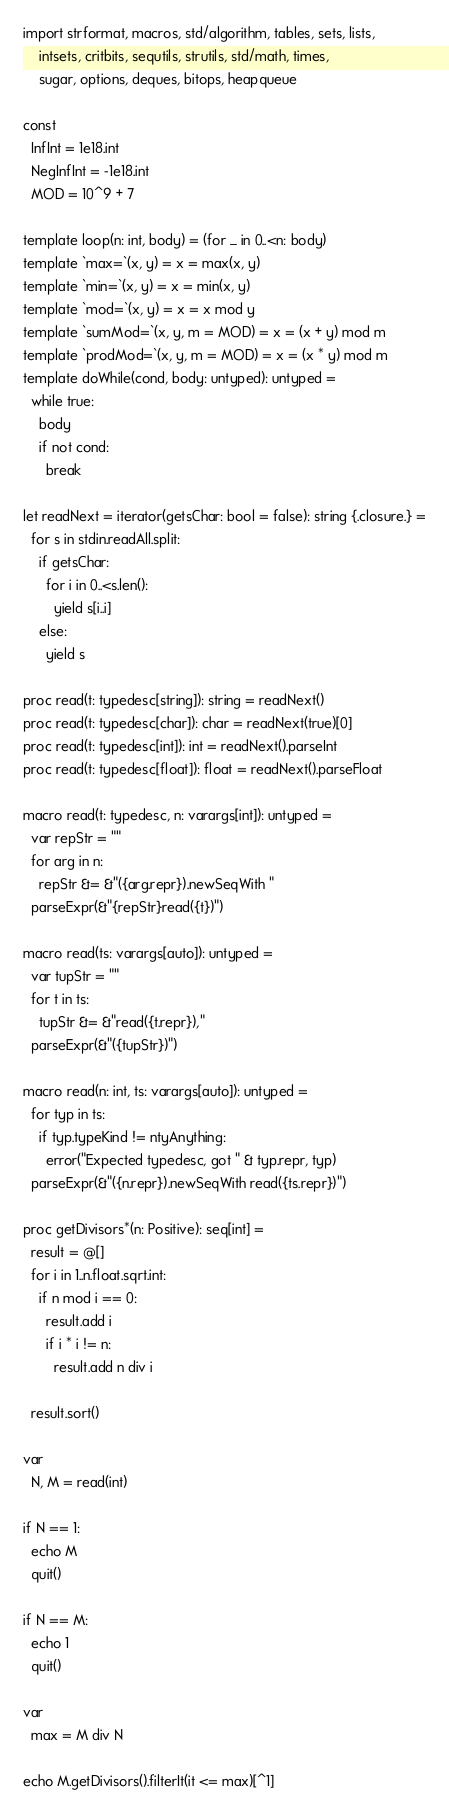<code> <loc_0><loc_0><loc_500><loc_500><_Nim_>import strformat, macros, std/algorithm, tables, sets, lists,
    intsets, critbits, sequtils, strutils, std/math, times,
    sugar, options, deques, bitops, heapqueue

const
  InfInt = 1e18.int
  NegInfInt = -1e18.int
  MOD = 10^9 + 7

template loop(n: int, body) = (for _ in 0..<n: body)
template `max=`(x, y) = x = max(x, y)
template `min=`(x, y) = x = min(x, y)
template `mod=`(x, y) = x = x mod y
template `sumMod=`(x, y, m = MOD) = x = (x + y) mod m
template `prodMod=`(x, y, m = MOD) = x = (x * y) mod m
template doWhile(cond, body: untyped): untyped =
  while true:
    body
    if not cond:
      break

let readNext = iterator(getsChar: bool = false): string {.closure.} =
  for s in stdin.readAll.split:
    if getsChar:
      for i in 0..<s.len():
        yield s[i..i]
    else:
      yield s

proc read(t: typedesc[string]): string = readNext()
proc read(t: typedesc[char]): char = readNext(true)[0]
proc read(t: typedesc[int]): int = readNext().parseInt
proc read(t: typedesc[float]): float = readNext().parseFloat

macro read(t: typedesc, n: varargs[int]): untyped =
  var repStr = ""
  for arg in n:
    repStr &= &"({arg.repr}).newSeqWith "
  parseExpr(&"{repStr}read({t})")

macro read(ts: varargs[auto]): untyped =
  var tupStr = ""
  for t in ts:
    tupStr &= &"read({t.repr}),"
  parseExpr(&"({tupStr})")

macro read(n: int, ts: varargs[auto]): untyped =
  for typ in ts:
    if typ.typeKind != ntyAnything:
      error("Expected typedesc, got " & typ.repr, typ)
  parseExpr(&"({n.repr}).newSeqWith read({ts.repr})")

proc getDivisors*(n: Positive): seq[int] =
  result = @[]
  for i in 1..n.float.sqrt.int:
    if n mod i == 0:
      result.add i
      if i * i != n:
        result.add n div i

  result.sort()

var
  N, M = read(int)

if N == 1:
  echo M
  quit()

if N == M:
  echo 1
  quit()

var
  max = M div N

echo M.getDivisors().filterIt(it <= max)[^1]
</code> 